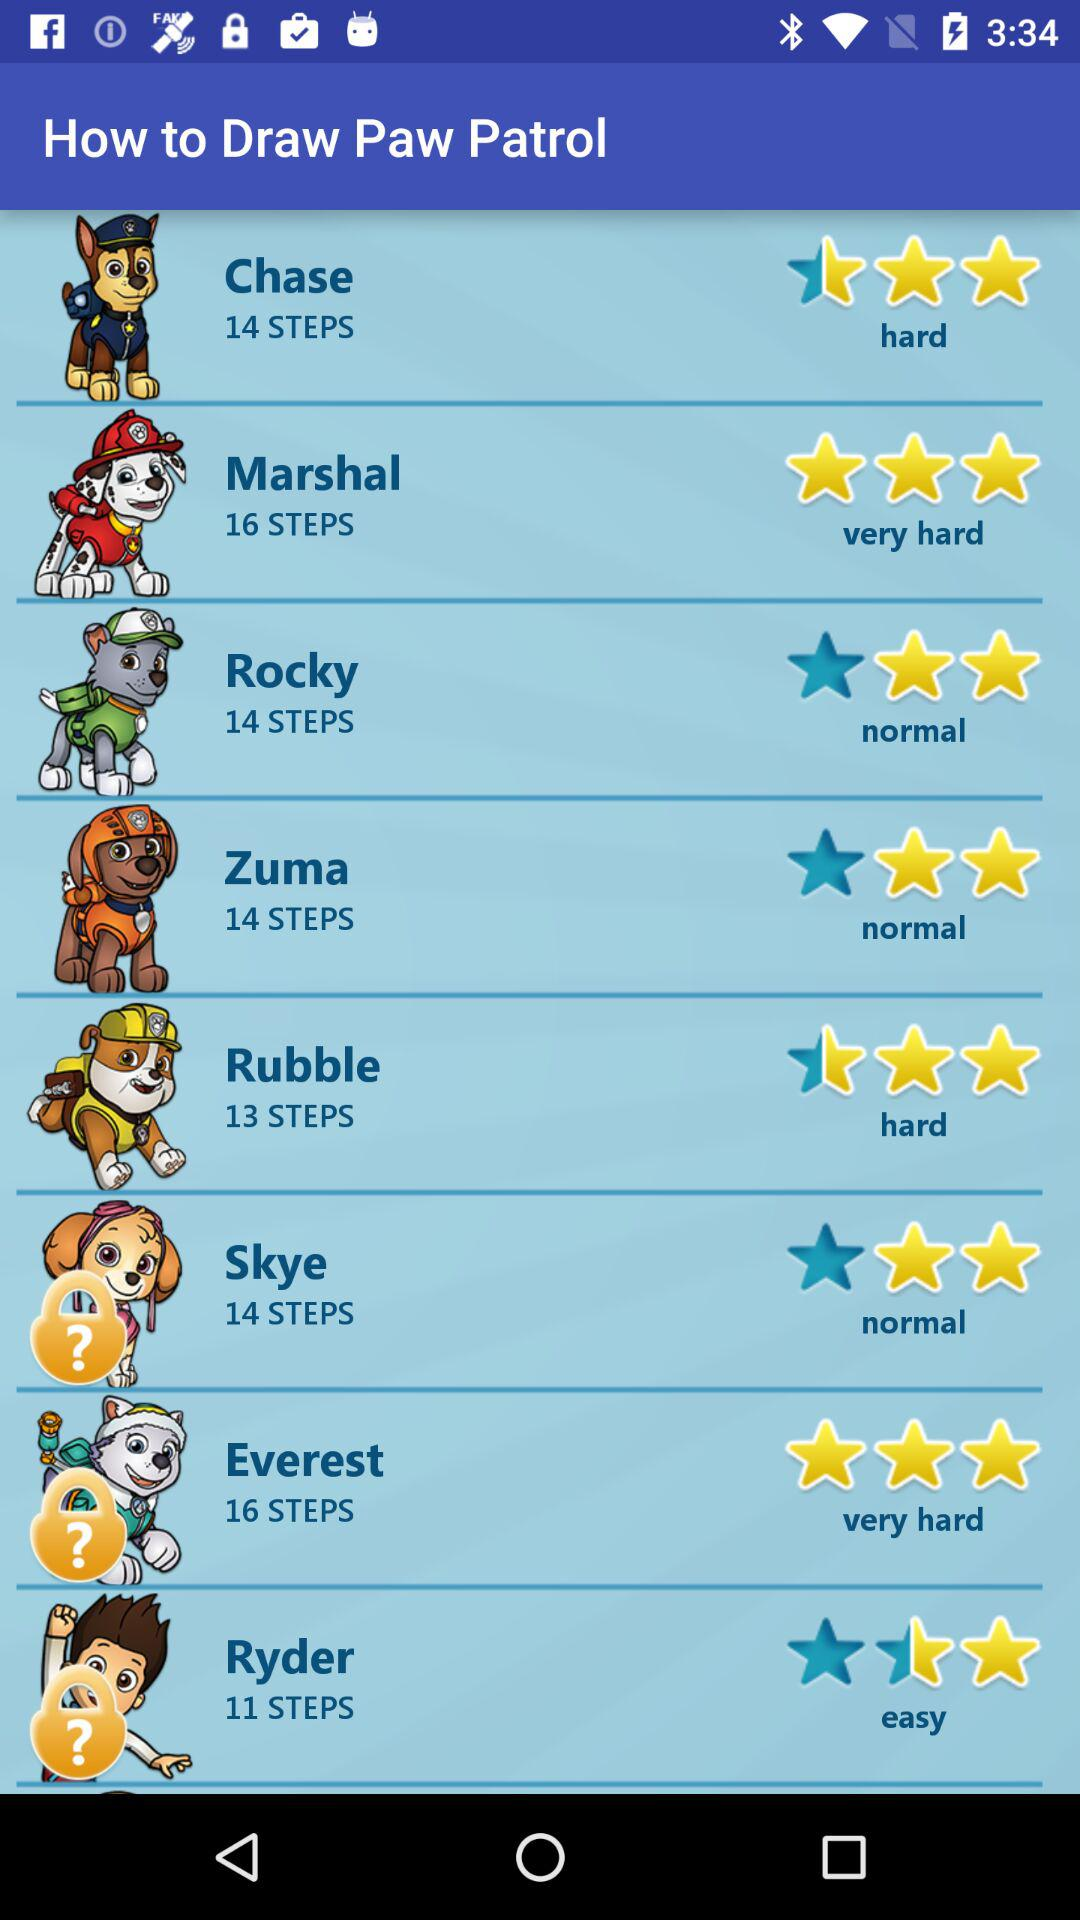How difficult is it to draw Chase? It is hard to draw Chase. 